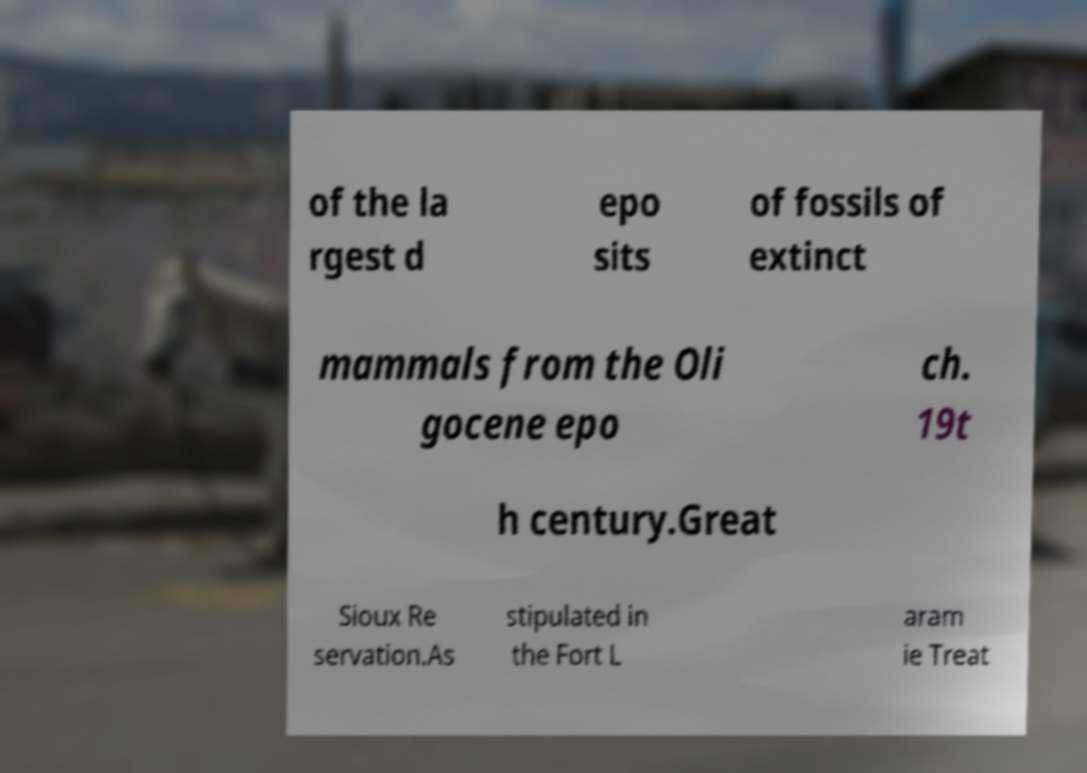There's text embedded in this image that I need extracted. Can you transcribe it verbatim? of the la rgest d epo sits of fossils of extinct mammals from the Oli gocene epo ch. 19t h century.Great Sioux Re servation.As stipulated in the Fort L aram ie Treat 